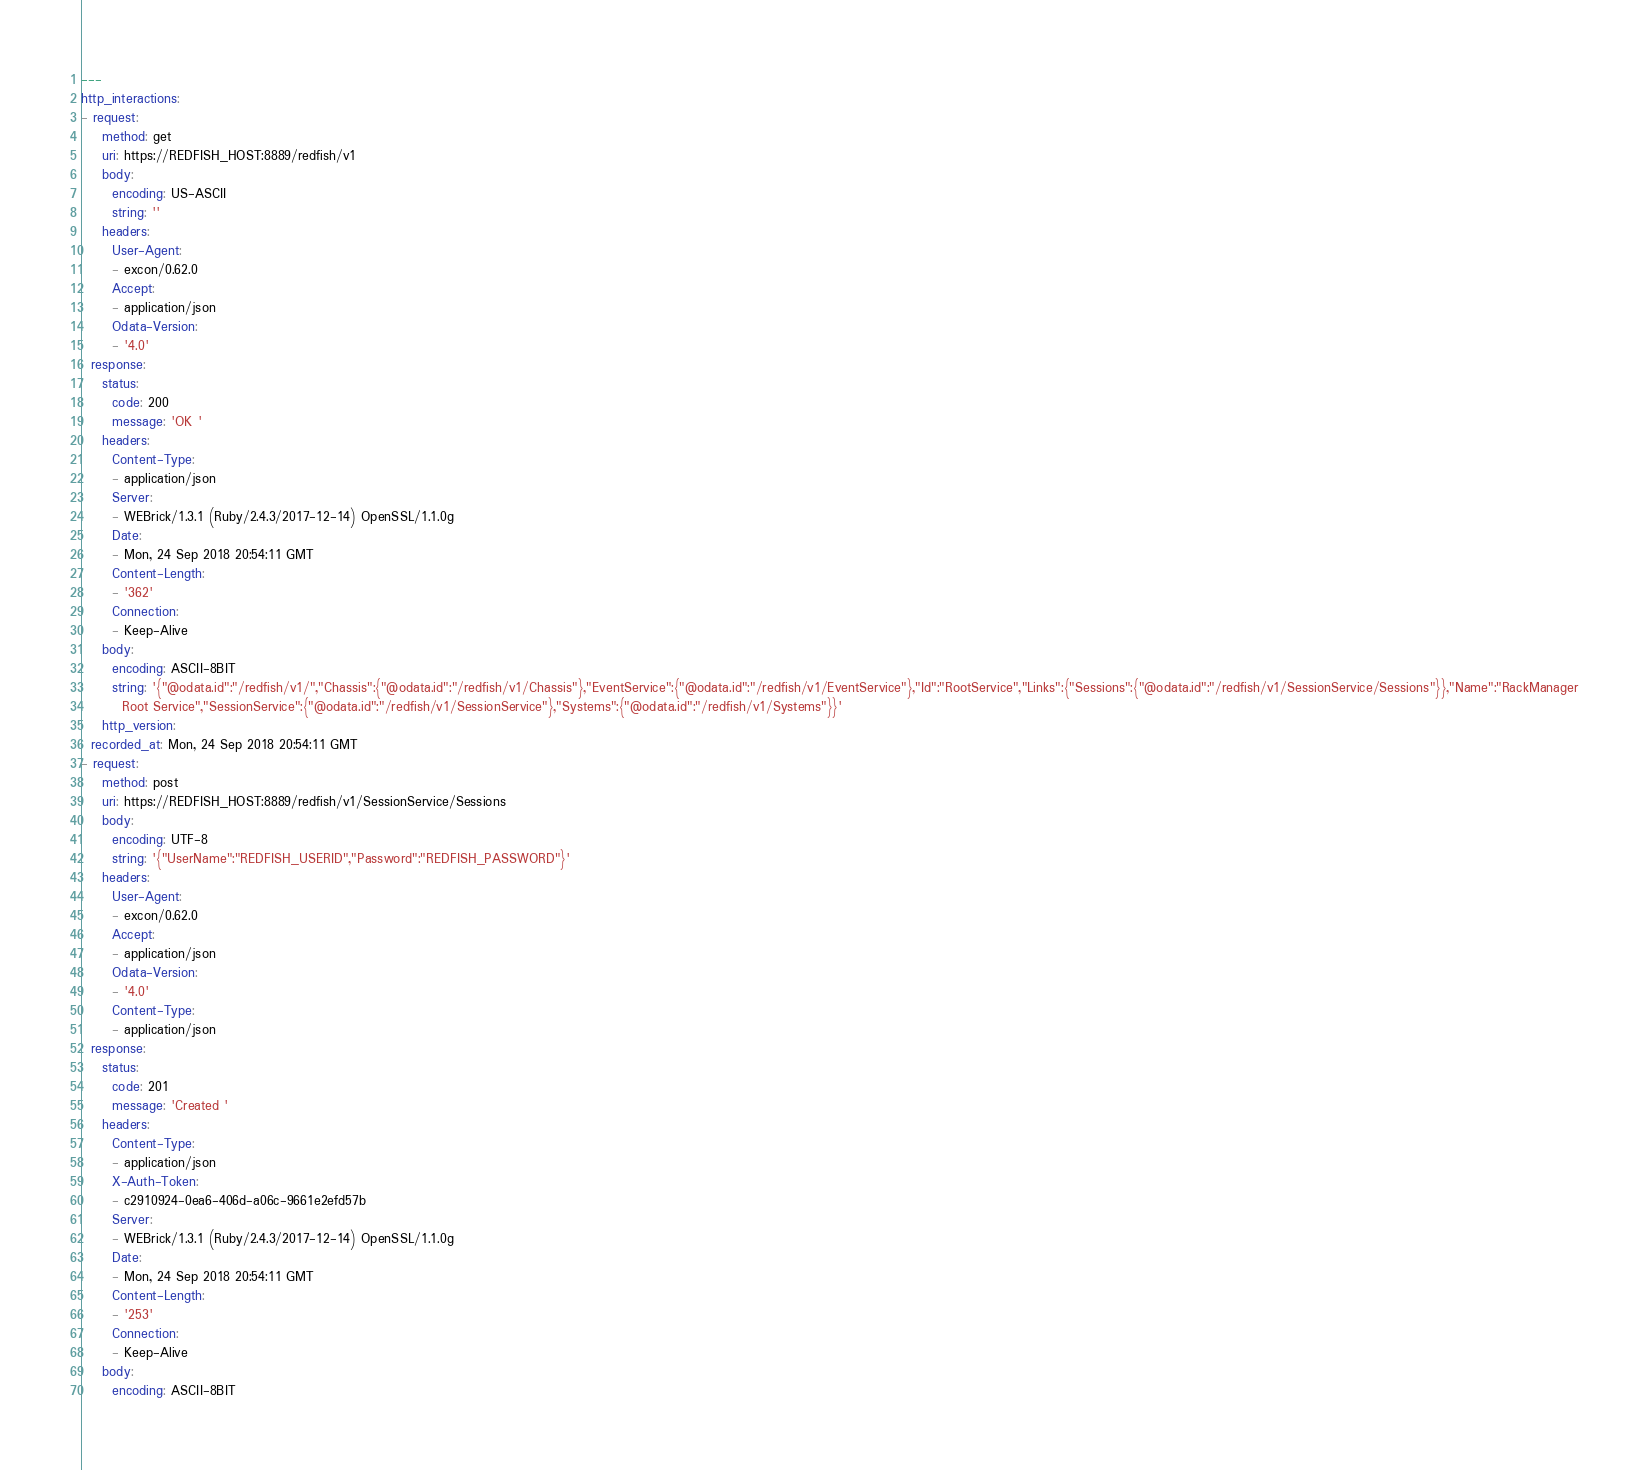Convert code to text. <code><loc_0><loc_0><loc_500><loc_500><_YAML_>---
http_interactions:
- request:
    method: get
    uri: https://REDFISH_HOST:8889/redfish/v1
    body:
      encoding: US-ASCII
      string: ''
    headers:
      User-Agent:
      - excon/0.62.0
      Accept:
      - application/json
      Odata-Version:
      - '4.0'
  response:
    status:
      code: 200
      message: 'OK '
    headers:
      Content-Type:
      - application/json
      Server:
      - WEBrick/1.3.1 (Ruby/2.4.3/2017-12-14) OpenSSL/1.1.0g
      Date:
      - Mon, 24 Sep 2018 20:54:11 GMT
      Content-Length:
      - '362'
      Connection:
      - Keep-Alive
    body:
      encoding: ASCII-8BIT
      string: '{"@odata.id":"/redfish/v1/","Chassis":{"@odata.id":"/redfish/v1/Chassis"},"EventService":{"@odata.id":"/redfish/v1/EventService"},"Id":"RootService","Links":{"Sessions":{"@odata.id":"/redfish/v1/SessionService/Sessions"}},"Name":"RackManager
        Root Service","SessionService":{"@odata.id":"/redfish/v1/SessionService"},"Systems":{"@odata.id":"/redfish/v1/Systems"}}'
    http_version: 
  recorded_at: Mon, 24 Sep 2018 20:54:11 GMT
- request:
    method: post
    uri: https://REDFISH_HOST:8889/redfish/v1/SessionService/Sessions
    body:
      encoding: UTF-8
      string: '{"UserName":"REDFISH_USERID","Password":"REDFISH_PASSWORD"}'
    headers:
      User-Agent:
      - excon/0.62.0
      Accept:
      - application/json
      Odata-Version:
      - '4.0'
      Content-Type:
      - application/json
  response:
    status:
      code: 201
      message: 'Created '
    headers:
      Content-Type:
      - application/json
      X-Auth-Token:
      - c2910924-0ea6-406d-a06c-9661e2efd57b
      Server:
      - WEBrick/1.3.1 (Ruby/2.4.3/2017-12-14) OpenSSL/1.1.0g
      Date:
      - Mon, 24 Sep 2018 20:54:11 GMT
      Content-Length:
      - '253'
      Connection:
      - Keep-Alive
    body:
      encoding: ASCII-8BIT</code> 